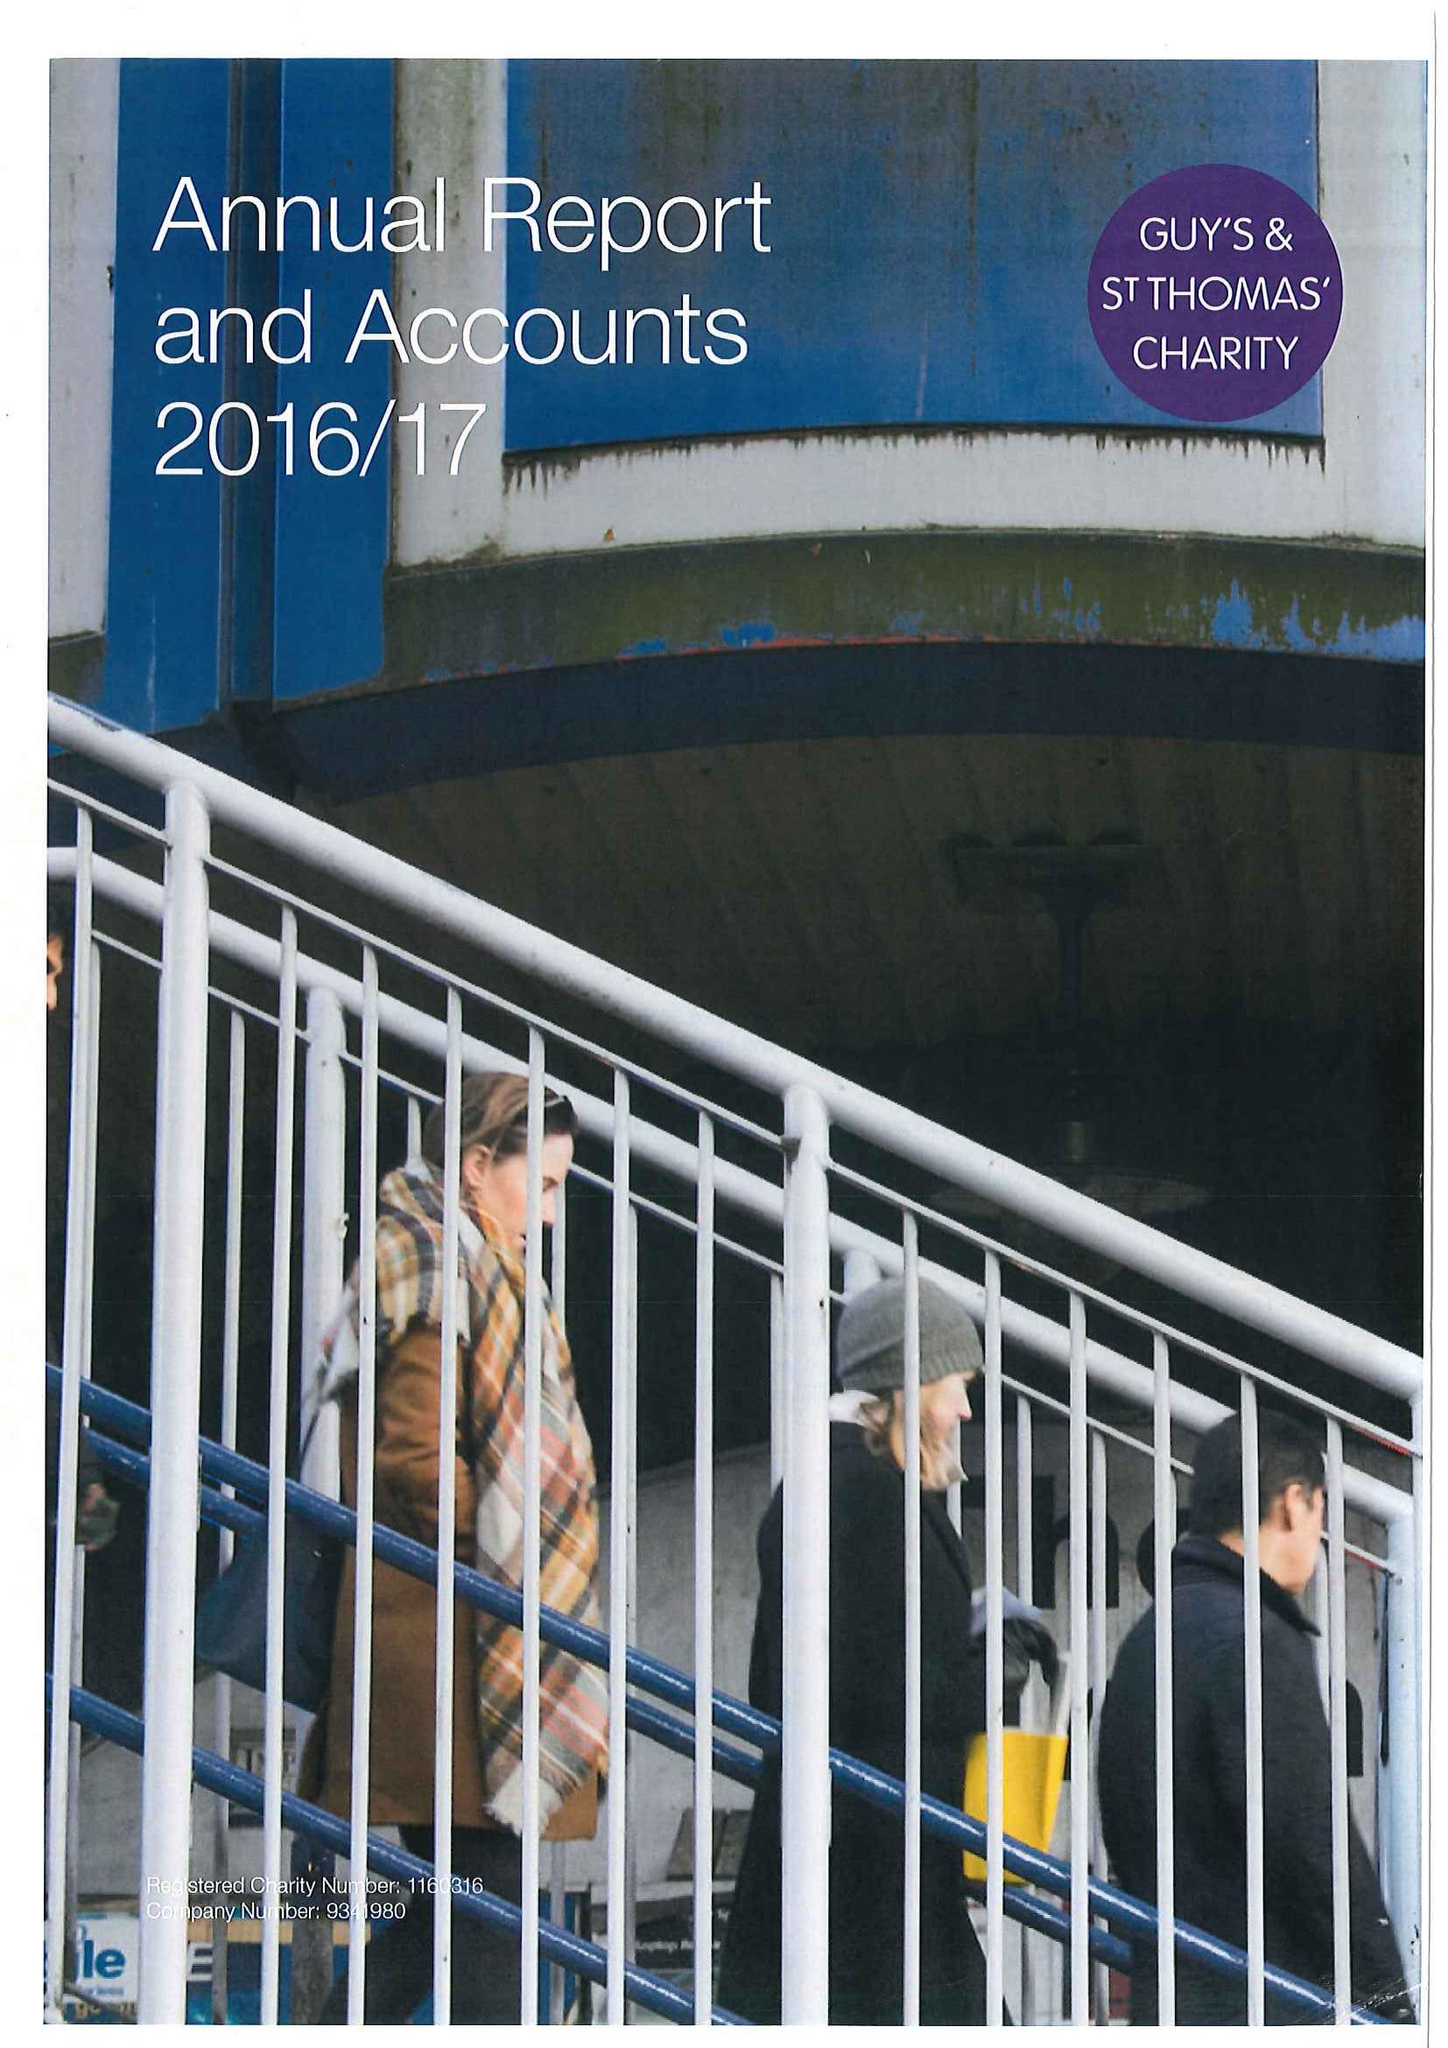What is the value for the charity_number?
Answer the question using a single word or phrase. 1160316 